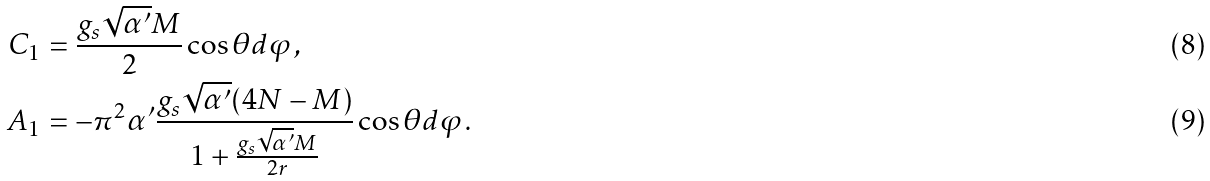Convert formula to latex. <formula><loc_0><loc_0><loc_500><loc_500>C _ { 1 } & = \frac { g _ { s } \sqrt { \alpha ^ { \prime } } M } { 2 } \cos \theta d \varphi \, , \\ A _ { 1 } & = - \pi ^ { 2 } \alpha ^ { \prime } \frac { g _ { s } \sqrt { \alpha ^ { \prime } } ( 4 N - M ) } { 1 + \frac { g _ { s } \sqrt { \alpha ^ { \prime } } M } { 2 r } } \cos \theta d \varphi \, .</formula> 